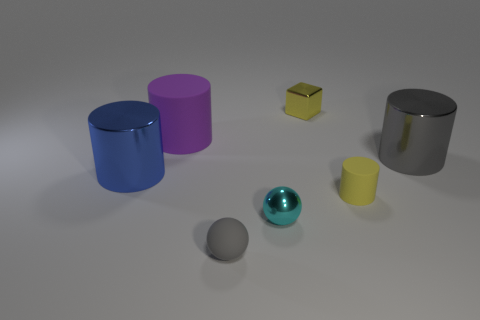What number of tiny yellow shiny cylinders are there?
Make the answer very short. 0. There is a yellow matte object; is its shape the same as the gray object that is behind the tiny cyan shiny sphere?
Ensure brevity in your answer.  Yes. There is a object that is behind the big purple matte thing; how big is it?
Give a very brief answer. Small. What is the material of the small cylinder?
Offer a very short reply. Rubber. Does the small shiny object behind the large matte cylinder have the same shape as the blue object?
Keep it short and to the point. No. The cylinder that is the same color as the small shiny cube is what size?
Make the answer very short. Small. Is there a gray sphere that has the same size as the cyan shiny object?
Make the answer very short. Yes. Is there a small metal sphere that is behind the large metallic thing left of the yellow object that is behind the big purple cylinder?
Make the answer very short. No. There is a metallic sphere; is its color the same as the large metal thing to the right of the metal block?
Your response must be concise. No. The gray object to the right of the gray thing that is to the left of the tiny matte thing on the right side of the small rubber ball is made of what material?
Make the answer very short. Metal. 